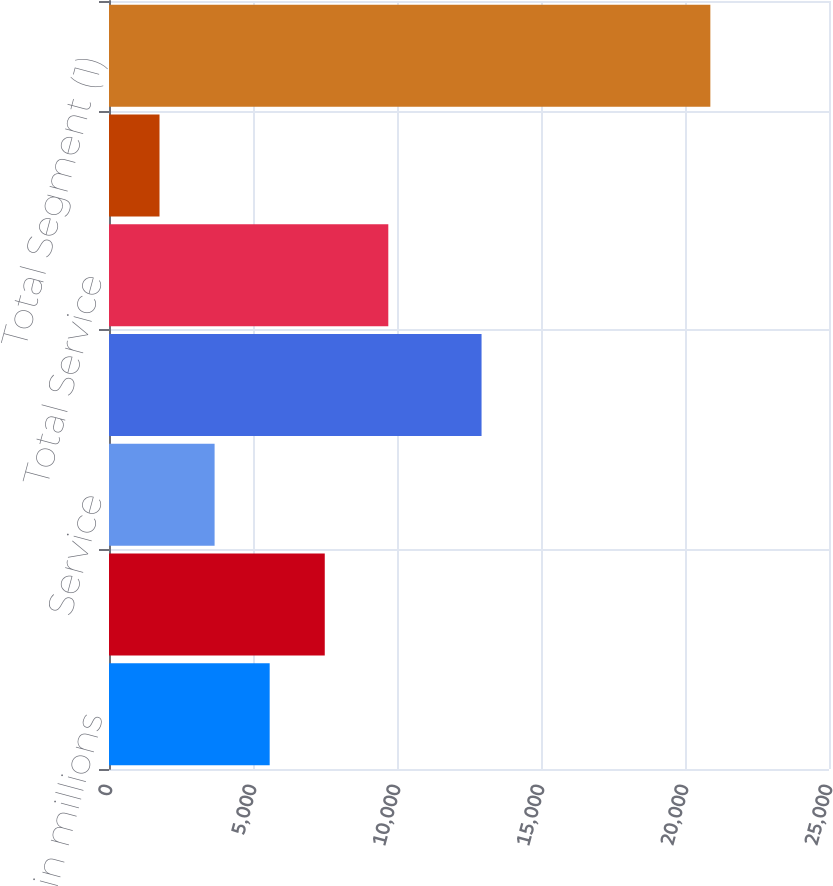Convert chart. <chart><loc_0><loc_0><loc_500><loc_500><bar_chart><fcel>in millions<fcel>Product<fcel>Service<fcel>Total Product<fcel>Total Service<fcel>Intersegment eliminations<fcel>Total Segment (1)<nl><fcel>5579.2<fcel>7491.8<fcel>3666.6<fcel>12936<fcel>9698<fcel>1754<fcel>20880<nl></chart> 